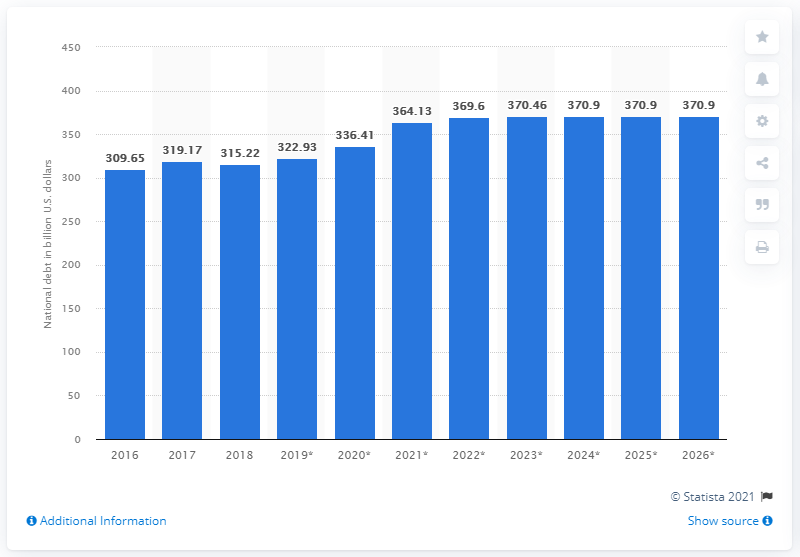List a handful of essential elements in this visual. In 2018, the national debt of Switzerland was approximately 315.22 billion dollars. 